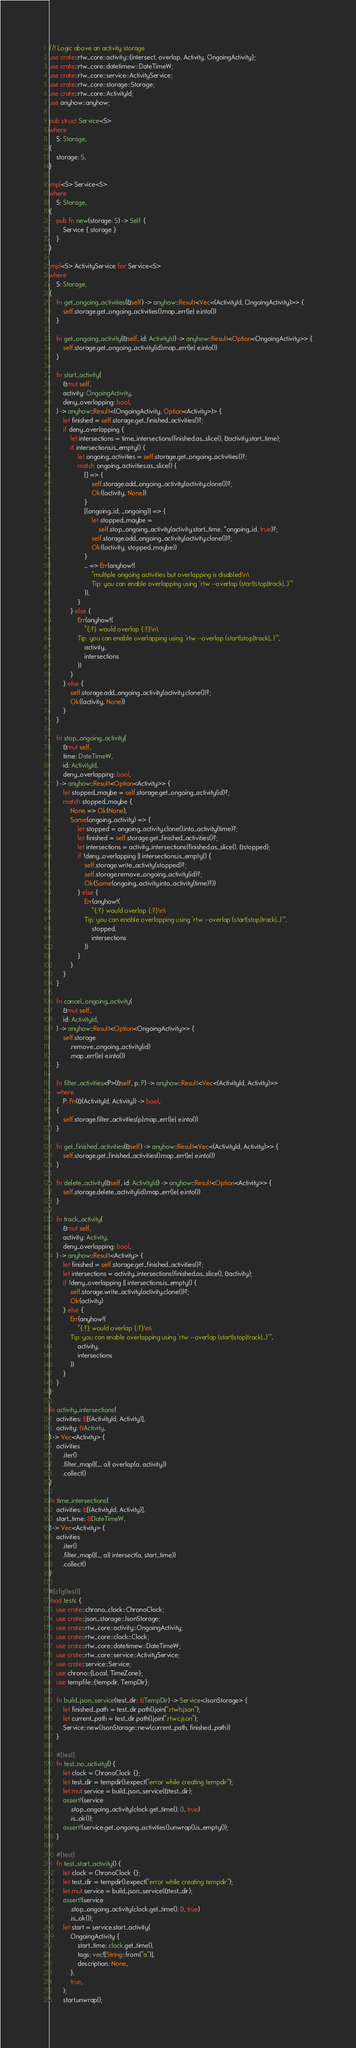<code> <loc_0><loc_0><loc_500><loc_500><_Rust_>//! Logic above an activity storage
use crate::rtw_core::activity::{intersect, overlap, Activity, OngoingActivity};
use crate::rtw_core::datetimew::DateTimeW;
use crate::rtw_core::service::ActivityService;
use crate::rtw_core::storage::Storage;
use crate::rtw_core::ActivityId;
use anyhow::anyhow;

pub struct Service<S>
where
    S: Storage,
{
    storage: S,
}

impl<S> Service<S>
where
    S: Storage,
{
    pub fn new(storage: S) -> Self {
        Service { storage }
    }
}

impl<S> ActivityService for Service<S>
where
    S: Storage,
{
    fn get_ongoing_activities(&self) -> anyhow::Result<Vec<(ActivityId, OngoingActivity)>> {
        self.storage.get_ongoing_activities().map_err(|e| e.into())
    }

    fn get_ongoing_activity(&self, id: ActivityId) -> anyhow::Result<Option<OngoingActivity>> {
        self.storage.get_ongoing_activity(id).map_err(|e| e.into())
    }

    fn start_activity(
        &mut self,
        activity: OngoingActivity,
        deny_overlapping: bool,
    ) -> anyhow::Result<(OngoingActivity, Option<Activity>)> {
        let finished = self.storage.get_finished_activities()?;
        if deny_overlapping {
            let intersections = time_intersections(finished.as_slice(), &activity.start_time);
            if intersections.is_empty() {
                let ongoing_activities = self.storage.get_ongoing_activities()?;
                match ongoing_activities.as_slice() {
                    [] => {
                        self.storage.add_ongoing_activity(activity.clone())?;
                        Ok((activity, None))
                    }
                    [(ongoing_id, _ongoing)] => {
                        let stopped_maybe =
                            self.stop_ongoing_activity(activity.start_time, *ongoing_id, true)?;
                        self.storage.add_ongoing_activity(activity.clone())?;
                        Ok((activity, stopped_maybe))
                    }
                    _ => Err(anyhow!(
                        "multiple ongoing activities but overlapping is disabled\n\
                        Tip: you can enable overlapping using `rtw --overlap (start|stop|track|...)`"
                    )),
                }
            } else {
                Err(anyhow!(
                    "{:?} would overlap {:?}\n\
                Tip: you can enable overlapping using `rtw --overlap (start|stop|track|...)`",
                    activity,
                    intersections
                ))
            }
        } else {
            self.storage.add_ongoing_activity(activity.clone())?;
            Ok((activity, None))
        }
    }

    fn stop_ongoing_activity(
        &mut self,
        time: DateTimeW,
        id: ActivityId,
        deny_overlapping: bool,
    ) -> anyhow::Result<Option<Activity>> {
        let stopped_maybe = self.storage.get_ongoing_activity(id)?;
        match stopped_maybe {
            None => Ok(None),
            Some(ongoing_activity) => {
                let stopped = ongoing_activity.clone().into_activity(time)?;
                let finished = self.storage.get_finished_activities()?;
                let intersections = activity_intersections(finished.as_slice(), &stopped);
                if !deny_overlapping || intersections.is_empty() {
                    self.storage.write_activity(stopped)?;
                    self.storage.remove_ongoing_activity(id)?;
                    Ok(Some(ongoing_activity.into_activity(time)?))
                } else {
                    Err(anyhow!(
                        "{:?} would overlap {:?}\n\
                    Tip: you can enable overlapping using `rtw --overlap (start|stop|track|...)`",
                        stopped,
                        intersections
                    ))
                }
            }
        }
    }

    fn cancel_ongoing_activity(
        &mut self,
        id: ActivityId,
    ) -> anyhow::Result<Option<OngoingActivity>> {
        self.storage
            .remove_ongoing_activity(id)
            .map_err(|e| e.into())
    }

    fn filter_activities<P>(&self, p: P) -> anyhow::Result<Vec<(ActivityId, Activity)>>
    where
        P: Fn(&(ActivityId, Activity)) -> bool,
    {
        self.storage.filter_activities(p).map_err(|e| e.into())
    }

    fn get_finished_activities(&self) -> anyhow::Result<Vec<(ActivityId, Activity)>> {
        self.storage.get_finished_activities().map_err(|e| e.into())
    }

    fn delete_activity(&self, id: ActivityId) -> anyhow::Result<Option<Activity>> {
        self.storage.delete_activity(id).map_err(|e| e.into())
    }

    fn track_activity(
        &mut self,
        activity: Activity,
        deny_overlapping: bool,
    ) -> anyhow::Result<Activity> {
        let finished = self.storage.get_finished_activities()?;
        let intersections = activity_intersections(finished.as_slice(), &activity);
        if !deny_overlapping || intersections.is_empty() {
            self.storage.write_activity(activity.clone())?;
            Ok(activity)
        } else {
            Err(anyhow!(
                "{:?} would overlap {:?}\n\
            Tip: you can enable overlapping using `rtw --overlap (start|stop|track|...)`",
                activity,
                intersections
            ))
        }
    }
}

fn activity_intersections(
    activities: &[(ActivityId, Activity)],
    activity: &Activity,
) -> Vec<Activity> {
    activities
        .iter()
        .filter_map(|(_, a)| overlap(a, activity))
        .collect()
}

fn time_intersections(
    activities: &[(ActivityId, Activity)],
    start_time: &DateTimeW,
) -> Vec<Activity> {
    activities
        .iter()
        .filter_map(|(_, a)| intersect(a, start_time))
        .collect()
}

#[cfg(test)]
mod tests {
    use crate::chrono_clock::ChronoClock;
    use crate::json_storage::JsonStorage;
    use crate::rtw_core::activity::OngoingActivity;
    use crate::rtw_core::clock::Clock;
    use crate::rtw_core::datetimew::DateTimeW;
    use crate::rtw_core::service::ActivityService;
    use crate::service::Service;
    use chrono::{Local, TimeZone};
    use tempfile::{tempdir, TempDir};

    fn build_json_service(test_dir: &TempDir) -> Service<JsonStorage> {
        let finished_path = test_dir.path().join(".rtwh.json");
        let current_path = test_dir.path().join(".rtwc.json");
        Service::new(JsonStorage::new(current_path, finished_path))
    }

    #[test]
    fn test_no_activity() {
        let clock = ChronoClock {};
        let test_dir = tempdir().expect("error while creating tempdir");
        let mut service = build_json_service(&test_dir);
        assert!(service
            .stop_ongoing_activity(clock.get_time(), 0, true)
            .is_ok());
        assert!(service.get_ongoing_activities().unwrap().is_empty());
    }

    #[test]
    fn test_start_activity() {
        let clock = ChronoClock {};
        let test_dir = tempdir().expect("error while creating tempdir");
        let mut service = build_json_service(&test_dir);
        assert!(service
            .stop_ongoing_activity(clock.get_time(), 0, true)
            .is_ok());
        let start = service.start_activity(
            OngoingActivity {
                start_time: clock.get_time(),
                tags: vec![String::from("a")],
                description: None,
            },
            true,
        );
        start.unwrap();</code> 